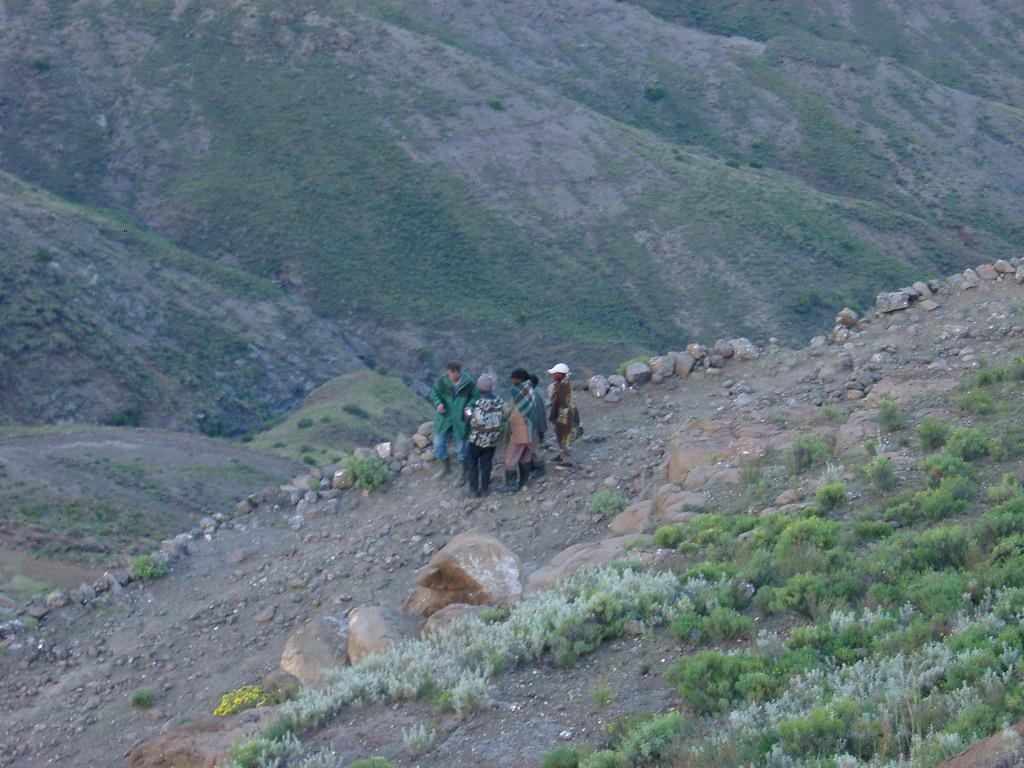What type of vegetation can be seen in the right corner of the image? There are plants in the right corner of the image. What other natural elements are present in the image? There are rocks visible in the image. Who or what is located in the foreground of the image? There are people in the foreground of the image. What type of landscape can be seen in the background of the image? There are mountains in the background of the image. What type of boat can be seen in the image? There is no boat present in the image. What meal is being prepared by the people in the foreground of the image? There is no meal preparation or indication of a meal in the image. 